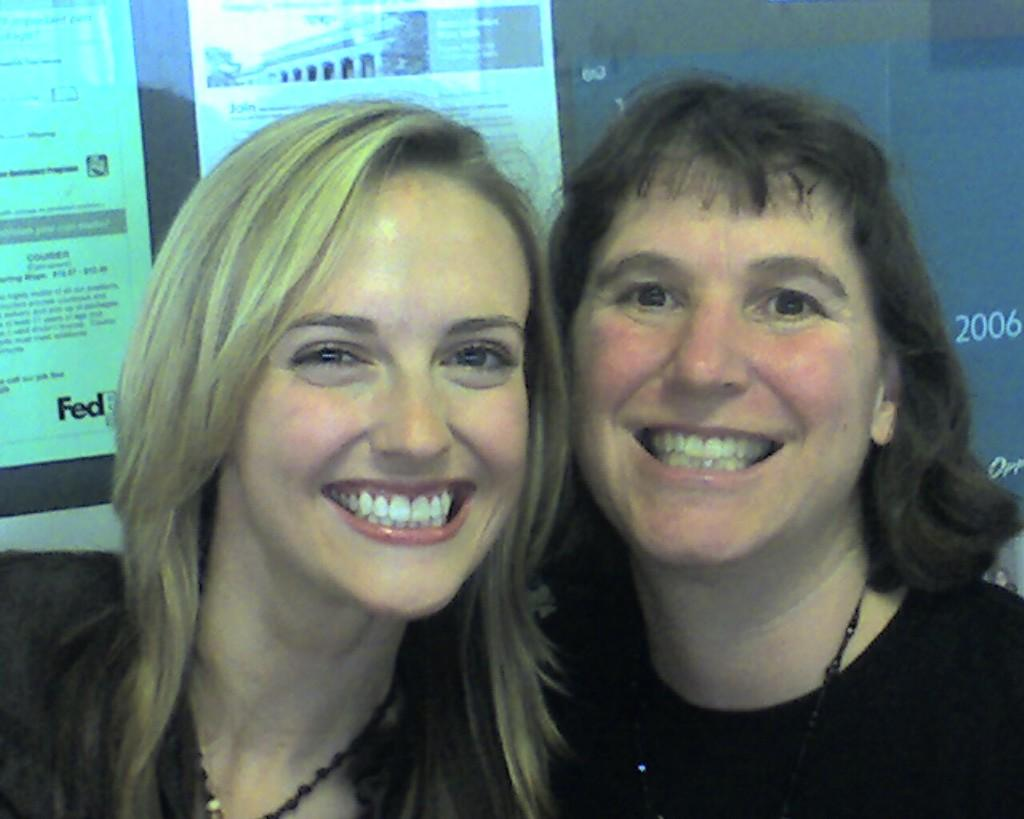How many people are present in the image? There are two ladies in the image. What can be seen in the background of the image? Papers with text can be seen in the background of the image. What type of snail can be seen crawling on the papers in the image? There is no snail present in the image; only the two ladies and papers with text are visible. 